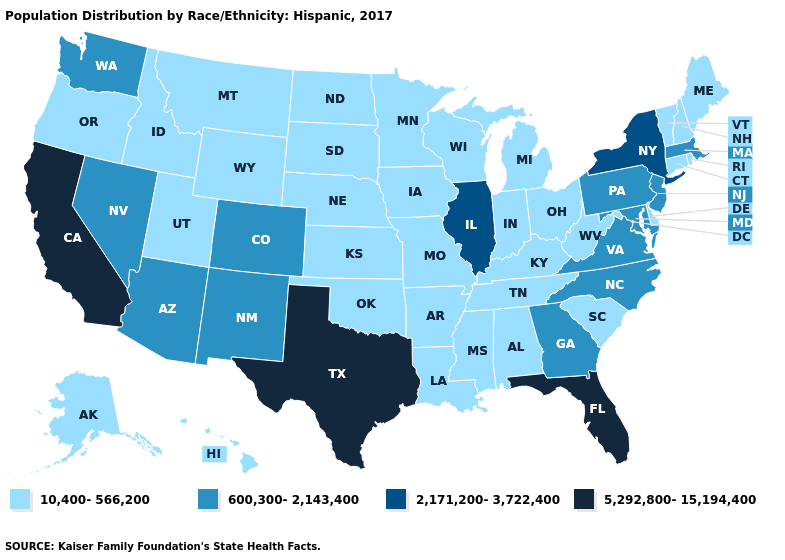Among the states that border Texas , does New Mexico have the lowest value?
Quick response, please. No. What is the lowest value in states that border Rhode Island?
Answer briefly. 10,400-566,200. What is the lowest value in states that border West Virginia?
Quick response, please. 10,400-566,200. Does California have the highest value in the West?
Concise answer only. Yes. Does the first symbol in the legend represent the smallest category?
Be succinct. Yes. What is the highest value in the USA?
Write a very short answer. 5,292,800-15,194,400. Among the states that border Kansas , which have the lowest value?
Give a very brief answer. Missouri, Nebraska, Oklahoma. What is the value of New York?
Give a very brief answer. 2,171,200-3,722,400. Which states hav the highest value in the Northeast?
Write a very short answer. New York. What is the value of Vermont?
Be succinct. 10,400-566,200. What is the value of Kentucky?
Write a very short answer. 10,400-566,200. What is the value of Oklahoma?
Be succinct. 10,400-566,200. Which states have the lowest value in the USA?
Quick response, please. Alabama, Alaska, Arkansas, Connecticut, Delaware, Hawaii, Idaho, Indiana, Iowa, Kansas, Kentucky, Louisiana, Maine, Michigan, Minnesota, Mississippi, Missouri, Montana, Nebraska, New Hampshire, North Dakota, Ohio, Oklahoma, Oregon, Rhode Island, South Carolina, South Dakota, Tennessee, Utah, Vermont, West Virginia, Wisconsin, Wyoming. Among the states that border Pennsylvania , which have the highest value?
Answer briefly. New York. Which states have the lowest value in the USA?
Answer briefly. Alabama, Alaska, Arkansas, Connecticut, Delaware, Hawaii, Idaho, Indiana, Iowa, Kansas, Kentucky, Louisiana, Maine, Michigan, Minnesota, Mississippi, Missouri, Montana, Nebraska, New Hampshire, North Dakota, Ohio, Oklahoma, Oregon, Rhode Island, South Carolina, South Dakota, Tennessee, Utah, Vermont, West Virginia, Wisconsin, Wyoming. 